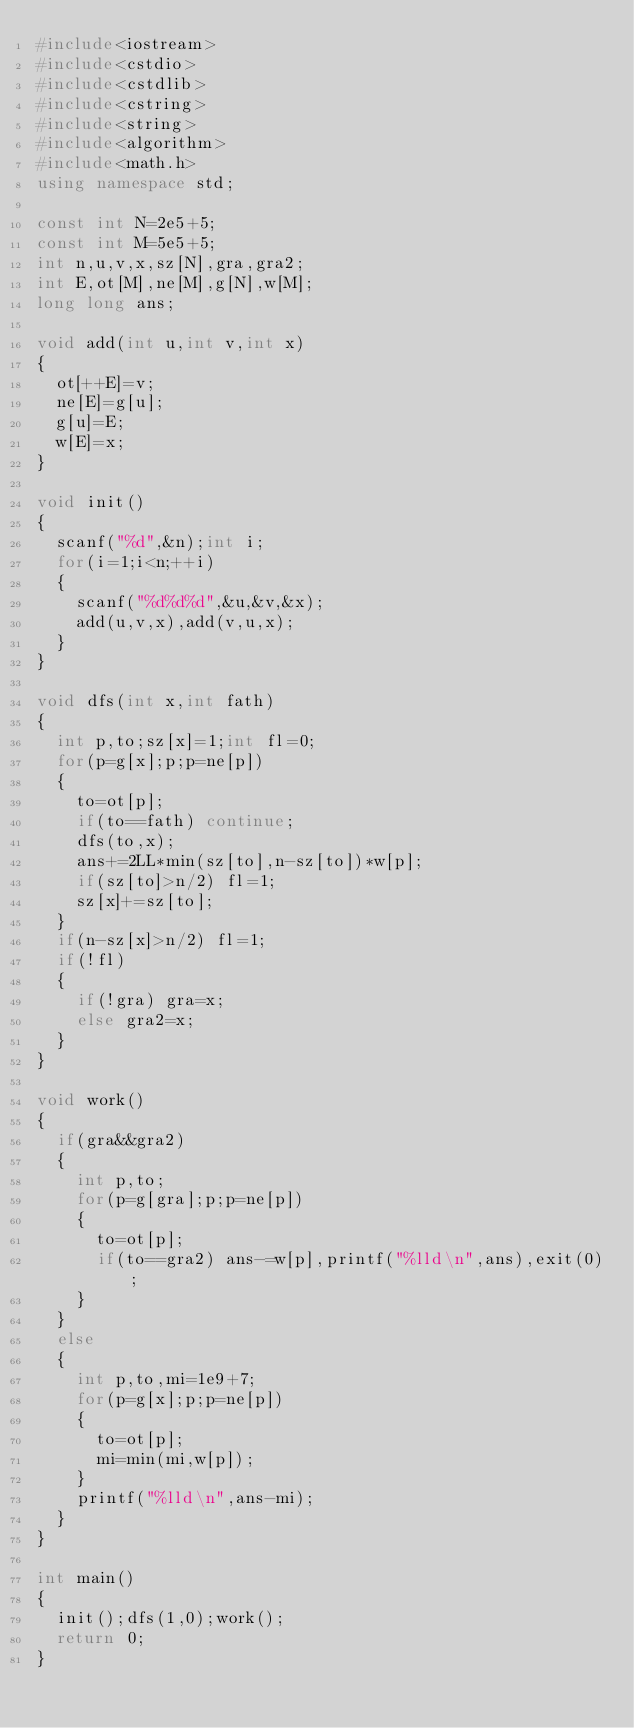Convert code to text. <code><loc_0><loc_0><loc_500><loc_500><_C++_>#include<iostream>
#include<cstdio>
#include<cstdlib>
#include<cstring>
#include<string>
#include<algorithm>
#include<math.h>
using namespace std;

const int N=2e5+5;
const int M=5e5+5;
int n,u,v,x,sz[N],gra,gra2;
int E,ot[M],ne[M],g[N],w[M];
long long ans;

void add(int u,int v,int x)
{
	ot[++E]=v;
	ne[E]=g[u];
	g[u]=E;
	w[E]=x;
}

void init()
{
	scanf("%d",&n);int i;
	for(i=1;i<n;++i)
	{
		scanf("%d%d%d",&u,&v,&x);
		add(u,v,x),add(v,u,x);
	}
}

void dfs(int x,int fath)
{
	int p,to;sz[x]=1;int fl=0;
	for(p=g[x];p;p=ne[p])
	{
		to=ot[p];
		if(to==fath) continue;
		dfs(to,x);
		ans+=2LL*min(sz[to],n-sz[to])*w[p];
		if(sz[to]>n/2) fl=1;
		sz[x]+=sz[to];
	}
	if(n-sz[x]>n/2) fl=1;
	if(!fl)
	{
		if(!gra) gra=x;
		else gra2=x;
	}
}

void work()
{
	if(gra&&gra2)
	{
		int p,to;
		for(p=g[gra];p;p=ne[p])
		{
			to=ot[p];
			if(to==gra2) ans-=w[p],printf("%lld\n",ans),exit(0);
		}
	}
	else
	{
		int p,to,mi=1e9+7;
		for(p=g[x];p;p=ne[p])
		{
			to=ot[p];
			mi=min(mi,w[p]);
		}
		printf("%lld\n",ans-mi);
	}
}

int main()
{
	init();dfs(1,0);work();
	return 0;
}</code> 